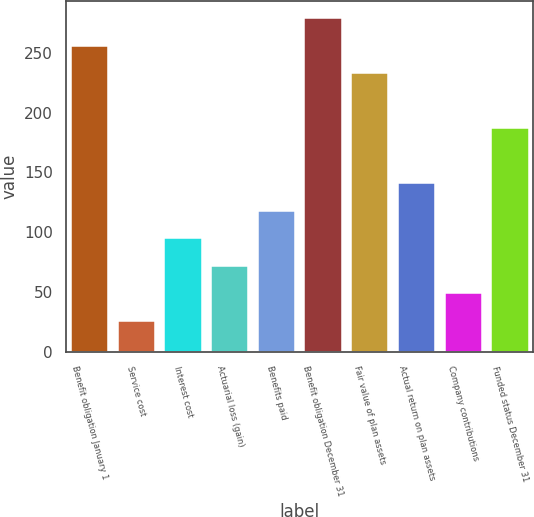<chart> <loc_0><loc_0><loc_500><loc_500><bar_chart><fcel>Benefit obligation January 1<fcel>Service cost<fcel>Interest cost<fcel>Actuarial loss (gain)<fcel>Benefits paid<fcel>Benefit obligation December 31<fcel>Fair value of plan assets<fcel>Actual return on plan assets<fcel>Company contributions<fcel>Funded status December 31<nl><fcel>256<fcel>26<fcel>95<fcel>72<fcel>118<fcel>279<fcel>233<fcel>141<fcel>49<fcel>187<nl></chart> 